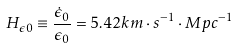Convert formula to latex. <formula><loc_0><loc_0><loc_500><loc_500>H _ { \epsilon 0 } \equiv \frac { \dot { \epsilon } _ { 0 } } { \epsilon _ { 0 } } = 5 . 4 2 k m \cdot s ^ { - 1 } \cdot M p c ^ { - 1 }</formula> 